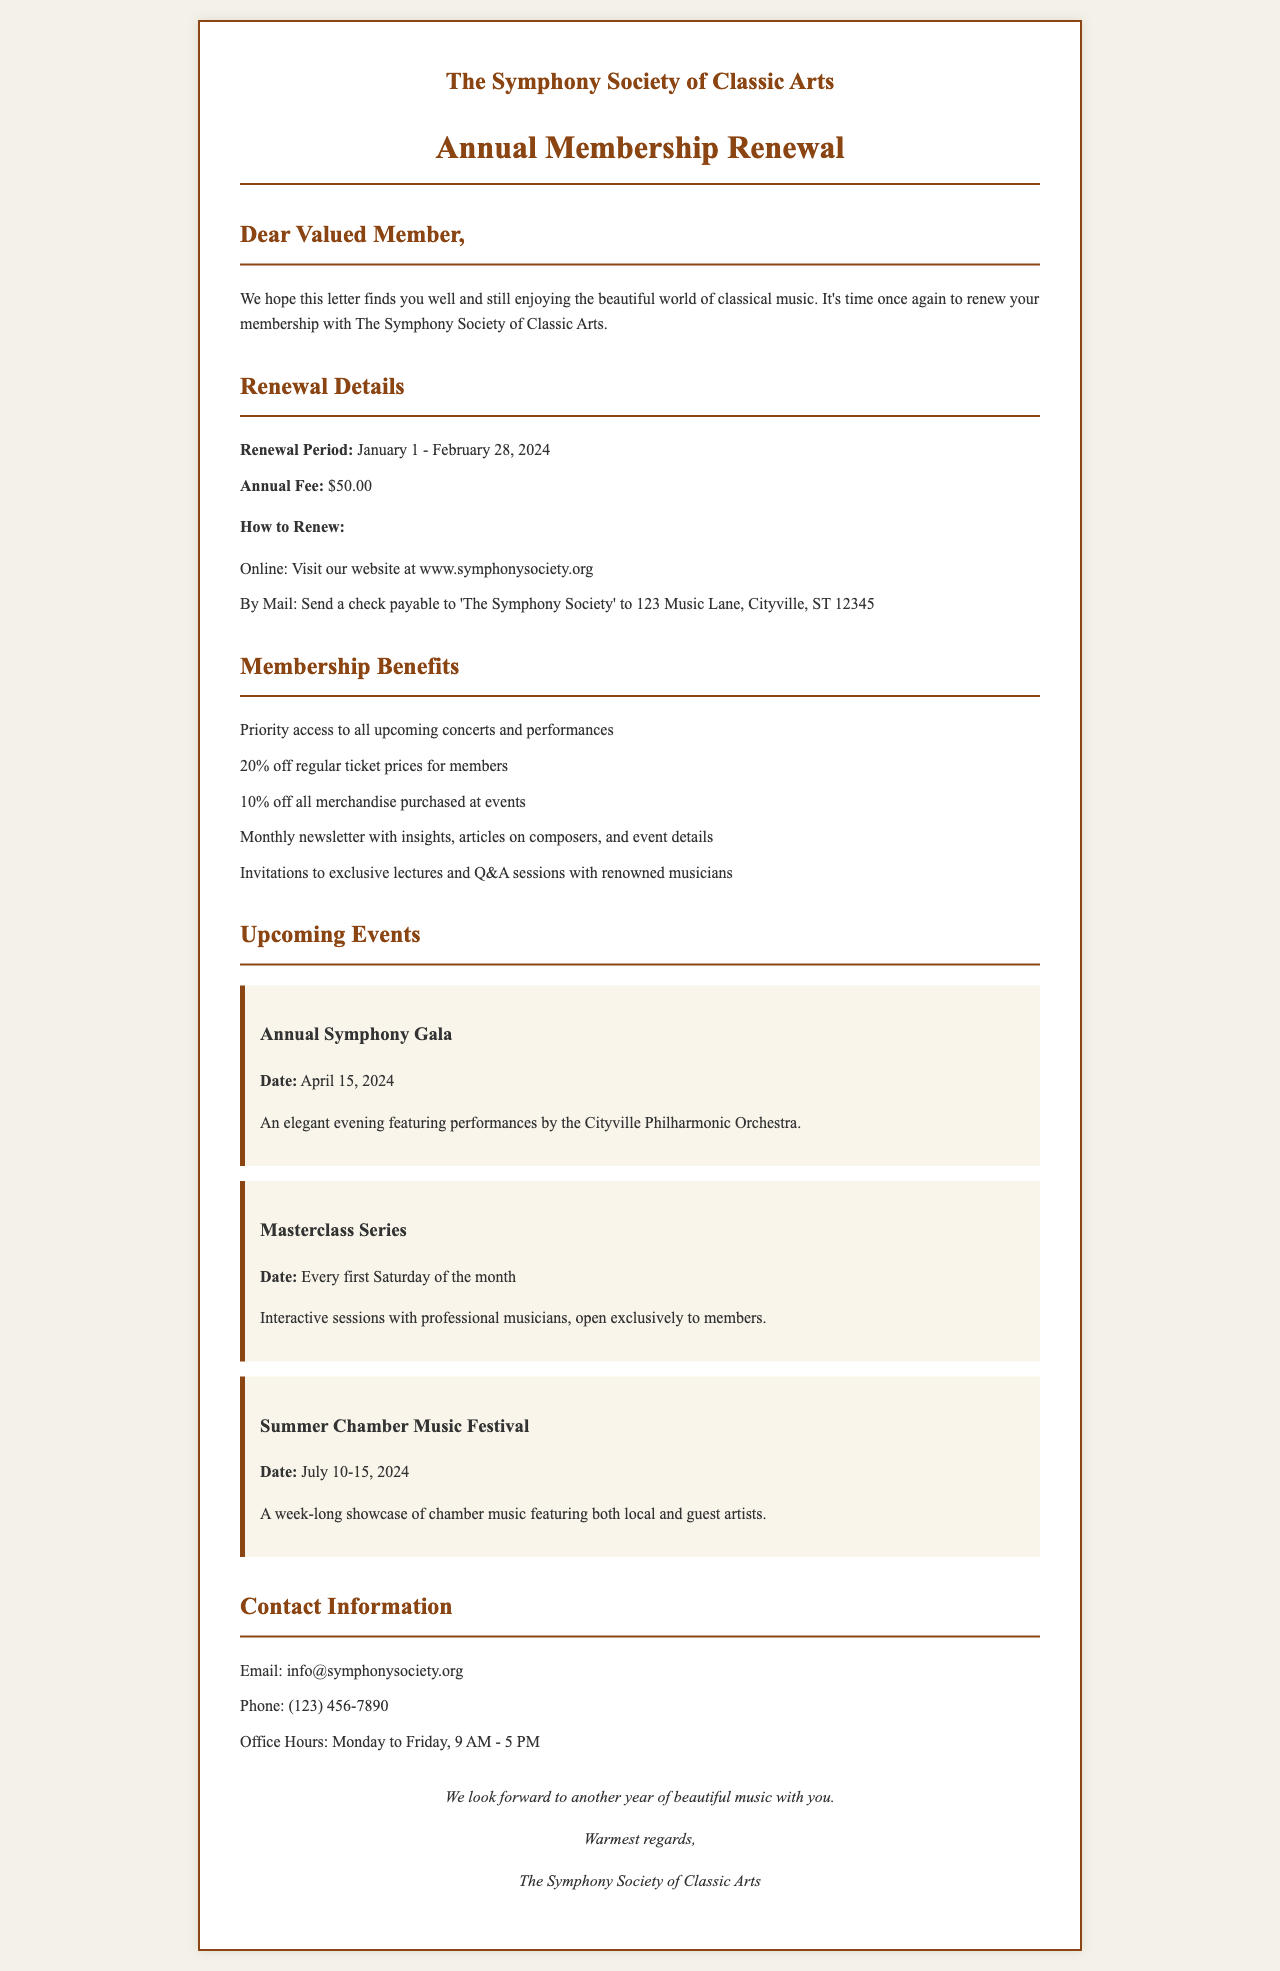What is the renewal period? The renewal period is stated as the timeframe during which members can renew their membership. It is from January 1 to February 28, 2024.
Answer: January 1 - February 28, 2024 What is the annual fee for membership? The annual fee is the amount that members are required to pay to maintain their membership, which is mentioned in the document.
Answer: $50.00 How can I renew my membership by mail? The document specifies the method for renewing by mail, including the payment method and address details.
Answer: Send a check payable to 'The Symphony Society' to 123 Music Lane, Cityville, ST 12345 What percentage discount do members receive on tickets? The document lists the benefits of membership, including the discount on ticket purchases for members.
Answer: 20% off What is one of the upcoming events? The document highlights various planned events, with specific details about each event.
Answer: Annual Symphony Gala What is the date of the Summer Chamber Music Festival? The date for this specific event is provided in the section on upcoming events, requiring knowledge of the event title and its time frame.
Answer: July 10-15, 2024 What kind of information is included in the monthly newsletter? The newsletter's content is mentioned as a benefit of membership, indicating the type of articles and insights it may contain.
Answer: Insights, articles on composers, and event details Who should I contact for more information? The contact information section lists specific details on how to reach out for inquiries, providing an email and phone number.
Answer: info@symphonysociety.org What day of the week are the Masterclass Series held? The document specifies the frequency and timing of the Masterclass Series event, which requires understanding its scheduling.
Answer: Every first Saturday of the month 